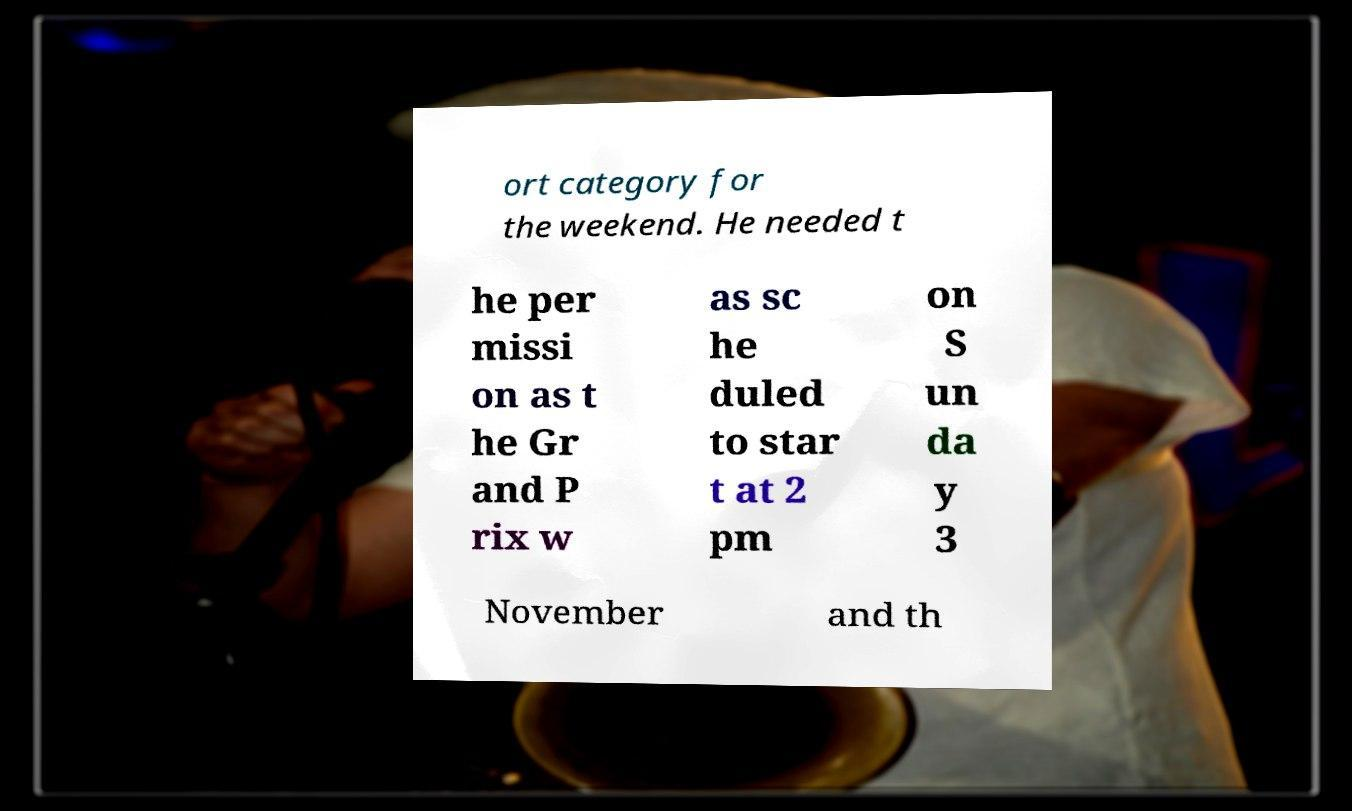There's text embedded in this image that I need extracted. Can you transcribe it verbatim? ort category for the weekend. He needed t he per missi on as t he Gr and P rix w as sc he duled to star t at 2 pm on S un da y 3 November and th 